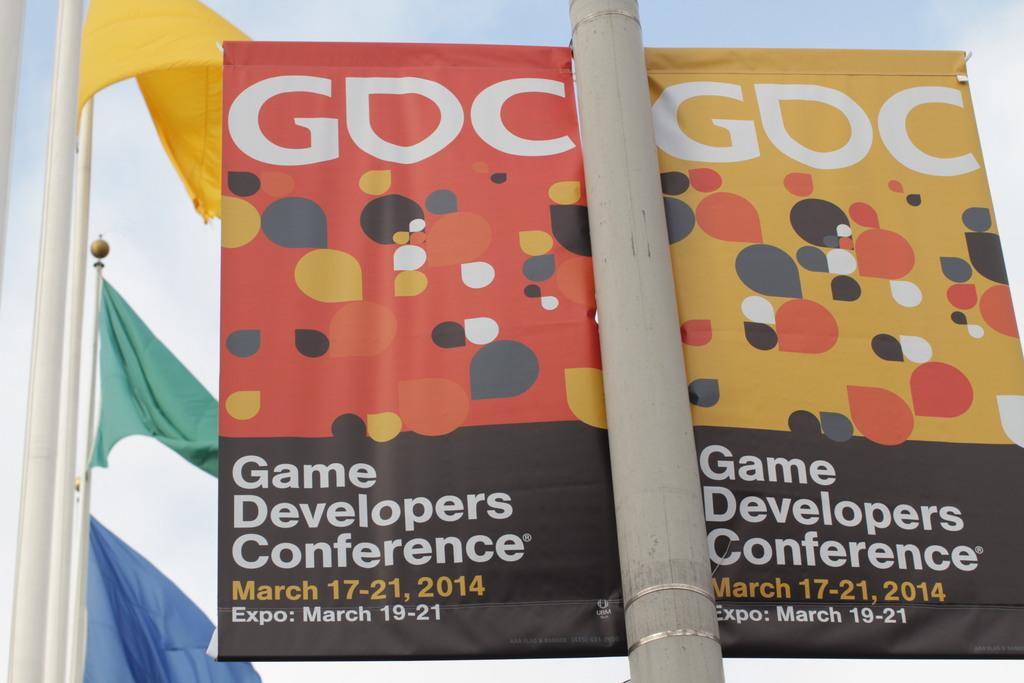<image>
Relay a brief, clear account of the picture shown. A banner promoting a game developers conference in March. 